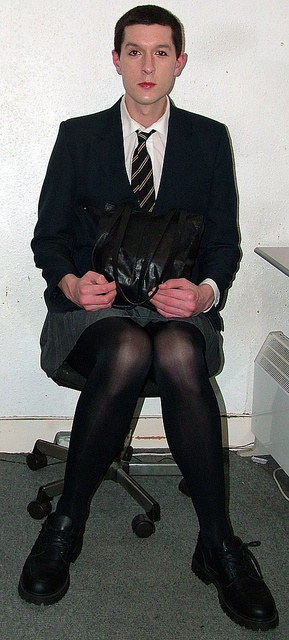Describe the objects in this image and their specific colors. I can see people in white, black, brown, gray, and lightgray tones, handbag in white, black, gray, darkgray, and purple tones, chair in white, black, and gray tones, tie in white, black, gray, and darkgray tones, and chair in white, black, gray, lightgray, and darkgray tones in this image. 